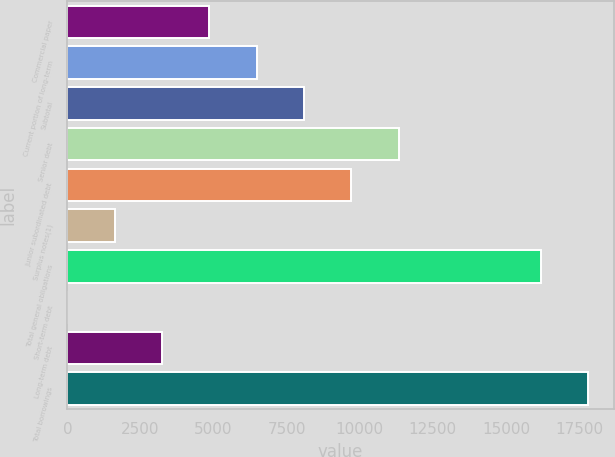Convert chart to OTSL. <chart><loc_0><loc_0><loc_500><loc_500><bar_chart><fcel>Commercial paper<fcel>Current portion of long-term<fcel>Subtotal<fcel>Senior debt<fcel>Junior subordinated debt<fcel>Surplus notes(1)<fcel>Total general obligations<fcel>Short-term debt<fcel>Long-term debt<fcel>Total borrowings<nl><fcel>4856.19<fcel>6474.45<fcel>8092.71<fcel>11329.2<fcel>9710.97<fcel>1619.67<fcel>16184<fcel>1.41<fcel>3237.93<fcel>17802.3<nl></chart> 